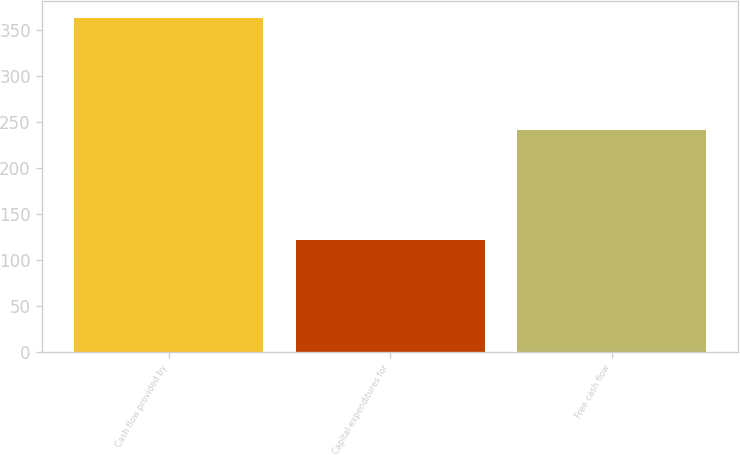Convert chart to OTSL. <chart><loc_0><loc_0><loc_500><loc_500><bar_chart><fcel>Cash flow provided by<fcel>Capital expenditures for<fcel>Free cash flow<nl><fcel>363.1<fcel>121.7<fcel>241.4<nl></chart> 